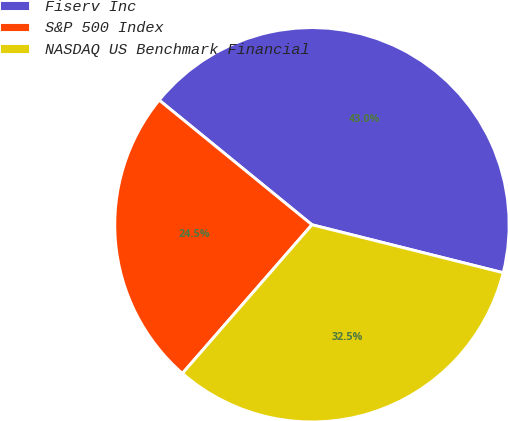<chart> <loc_0><loc_0><loc_500><loc_500><pie_chart><fcel>Fiserv Inc<fcel>S&P 500 Index<fcel>NASDAQ US Benchmark Financial<nl><fcel>43.02%<fcel>24.48%<fcel>32.5%<nl></chart> 